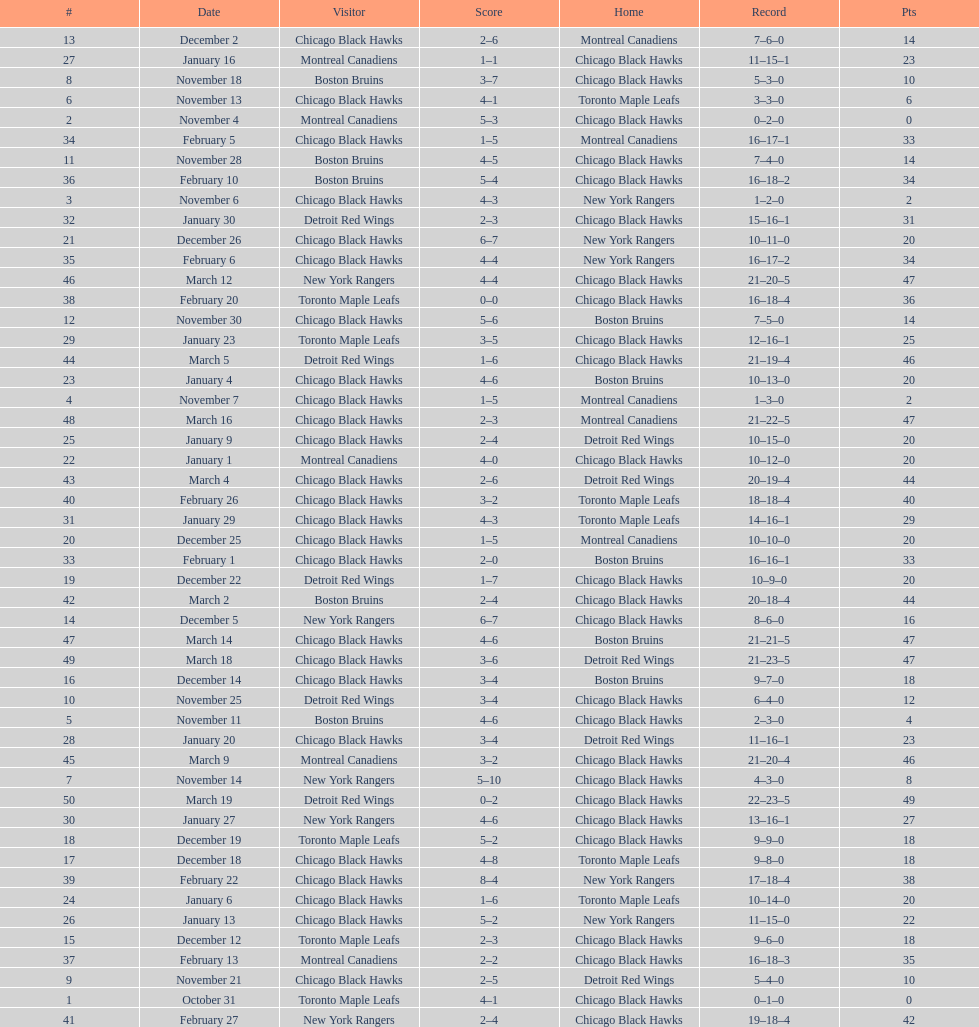Give me the full table as a dictionary. {'header': ['#', 'Date', 'Visitor', 'Score', 'Home', 'Record', 'Pts'], 'rows': [['13', 'December 2', 'Chicago Black Hawks', '2–6', 'Montreal Canadiens', '7–6–0', '14'], ['27', 'January 16', 'Montreal Canadiens', '1–1', 'Chicago Black Hawks', '11–15–1', '23'], ['8', 'November 18', 'Boston Bruins', '3–7', 'Chicago Black Hawks', '5–3–0', '10'], ['6', 'November 13', 'Chicago Black Hawks', '4–1', 'Toronto Maple Leafs', '3–3–0', '6'], ['2', 'November 4', 'Montreal Canadiens', '5–3', 'Chicago Black Hawks', '0–2–0', '0'], ['34', 'February 5', 'Chicago Black Hawks', '1–5', 'Montreal Canadiens', '16–17–1', '33'], ['11', 'November 28', 'Boston Bruins', '4–5', 'Chicago Black Hawks', '7–4–0', '14'], ['36', 'February 10', 'Boston Bruins', '5–4', 'Chicago Black Hawks', '16–18–2', '34'], ['3', 'November 6', 'Chicago Black Hawks', '4–3', 'New York Rangers', '1–2–0', '2'], ['32', 'January 30', 'Detroit Red Wings', '2–3', 'Chicago Black Hawks', '15–16–1', '31'], ['21', 'December 26', 'Chicago Black Hawks', '6–7', 'New York Rangers', '10–11–0', '20'], ['35', 'February 6', 'Chicago Black Hawks', '4–4', 'New York Rangers', '16–17–2', '34'], ['46', 'March 12', 'New York Rangers', '4–4', 'Chicago Black Hawks', '21–20–5', '47'], ['38', 'February 20', 'Toronto Maple Leafs', '0–0', 'Chicago Black Hawks', '16–18–4', '36'], ['12', 'November 30', 'Chicago Black Hawks', '5–6', 'Boston Bruins', '7–5–0', '14'], ['29', 'January 23', 'Toronto Maple Leafs', '3–5', 'Chicago Black Hawks', '12–16–1', '25'], ['44', 'March 5', 'Detroit Red Wings', '1–6', 'Chicago Black Hawks', '21–19–4', '46'], ['23', 'January 4', 'Chicago Black Hawks', '4–6', 'Boston Bruins', '10–13–0', '20'], ['4', 'November 7', 'Chicago Black Hawks', '1–5', 'Montreal Canadiens', '1–3–0', '2'], ['48', 'March 16', 'Chicago Black Hawks', '2–3', 'Montreal Canadiens', '21–22–5', '47'], ['25', 'January 9', 'Chicago Black Hawks', '2–4', 'Detroit Red Wings', '10–15–0', '20'], ['22', 'January 1', 'Montreal Canadiens', '4–0', 'Chicago Black Hawks', '10–12–0', '20'], ['43', 'March 4', 'Chicago Black Hawks', '2–6', 'Detroit Red Wings', '20–19–4', '44'], ['40', 'February 26', 'Chicago Black Hawks', '3–2', 'Toronto Maple Leafs', '18–18–4', '40'], ['31', 'January 29', 'Chicago Black Hawks', '4–3', 'Toronto Maple Leafs', '14–16–1', '29'], ['20', 'December 25', 'Chicago Black Hawks', '1–5', 'Montreal Canadiens', '10–10–0', '20'], ['33', 'February 1', 'Chicago Black Hawks', '2–0', 'Boston Bruins', '16–16–1', '33'], ['19', 'December 22', 'Detroit Red Wings', '1–7', 'Chicago Black Hawks', '10–9–0', '20'], ['42', 'March 2', 'Boston Bruins', '2–4', 'Chicago Black Hawks', '20–18–4', '44'], ['14', 'December 5', 'New York Rangers', '6–7', 'Chicago Black Hawks', '8–6–0', '16'], ['47', 'March 14', 'Chicago Black Hawks', '4–6', 'Boston Bruins', '21–21–5', '47'], ['49', 'March 18', 'Chicago Black Hawks', '3–6', 'Detroit Red Wings', '21–23–5', '47'], ['16', 'December 14', 'Chicago Black Hawks', '3–4', 'Boston Bruins', '9–7–0', '18'], ['10', 'November 25', 'Detroit Red Wings', '3–4', 'Chicago Black Hawks', '6–4–0', '12'], ['5', 'November 11', 'Boston Bruins', '4–6', 'Chicago Black Hawks', '2–3–0', '4'], ['28', 'January 20', 'Chicago Black Hawks', '3–4', 'Detroit Red Wings', '11–16–1', '23'], ['45', 'March 9', 'Montreal Canadiens', '3–2', 'Chicago Black Hawks', '21–20–4', '46'], ['7', 'November 14', 'New York Rangers', '5–10', 'Chicago Black Hawks', '4–3–0', '8'], ['50', 'March 19', 'Detroit Red Wings', '0–2', 'Chicago Black Hawks', '22–23–5', '49'], ['30', 'January 27', 'New York Rangers', '4–6', 'Chicago Black Hawks', '13–16–1', '27'], ['18', 'December 19', 'Toronto Maple Leafs', '5–2', 'Chicago Black Hawks', '9–9–0', '18'], ['17', 'December 18', 'Chicago Black Hawks', '4–8', 'Toronto Maple Leafs', '9–8–0', '18'], ['39', 'February 22', 'Chicago Black Hawks', '8–4', 'New York Rangers', '17–18–4', '38'], ['24', 'January 6', 'Chicago Black Hawks', '1–6', 'Toronto Maple Leafs', '10–14–0', '20'], ['26', 'January 13', 'Chicago Black Hawks', '5–2', 'New York Rangers', '11–15–0', '22'], ['15', 'December 12', 'Toronto Maple Leafs', '2–3', 'Chicago Black Hawks', '9–6–0', '18'], ['37', 'February 13', 'Montreal Canadiens', '2–2', 'Chicago Black Hawks', '16–18–3', '35'], ['9', 'November 21', 'Chicago Black Hawks', '2–5', 'Detroit Red Wings', '5–4–0', '10'], ['1', 'October 31', 'Toronto Maple Leafs', '4–1', 'Chicago Black Hawks', '0–1–0', '0'], ['41', 'February 27', 'New York Rangers', '2–4', 'Chicago Black Hawks', '19–18–4', '42']]} Who was the next team that the boston bruins played after november 11? Chicago Black Hawks. 